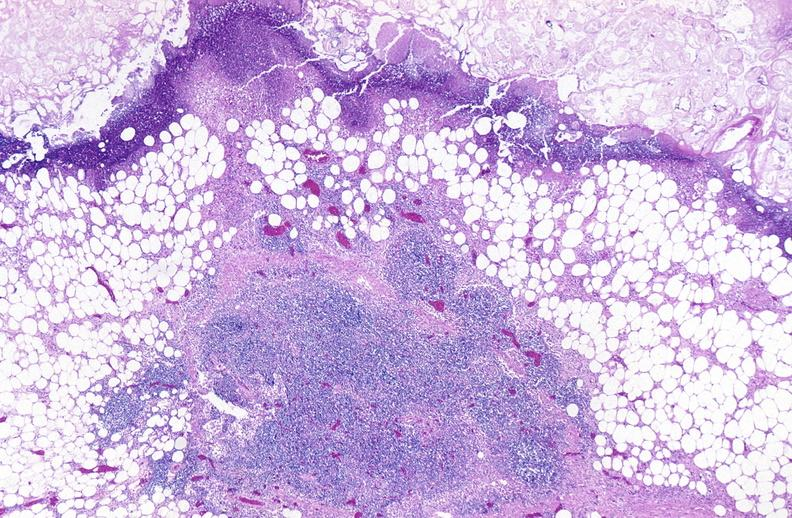where is this?
Answer the question using a single word or phrase. Pancreas 